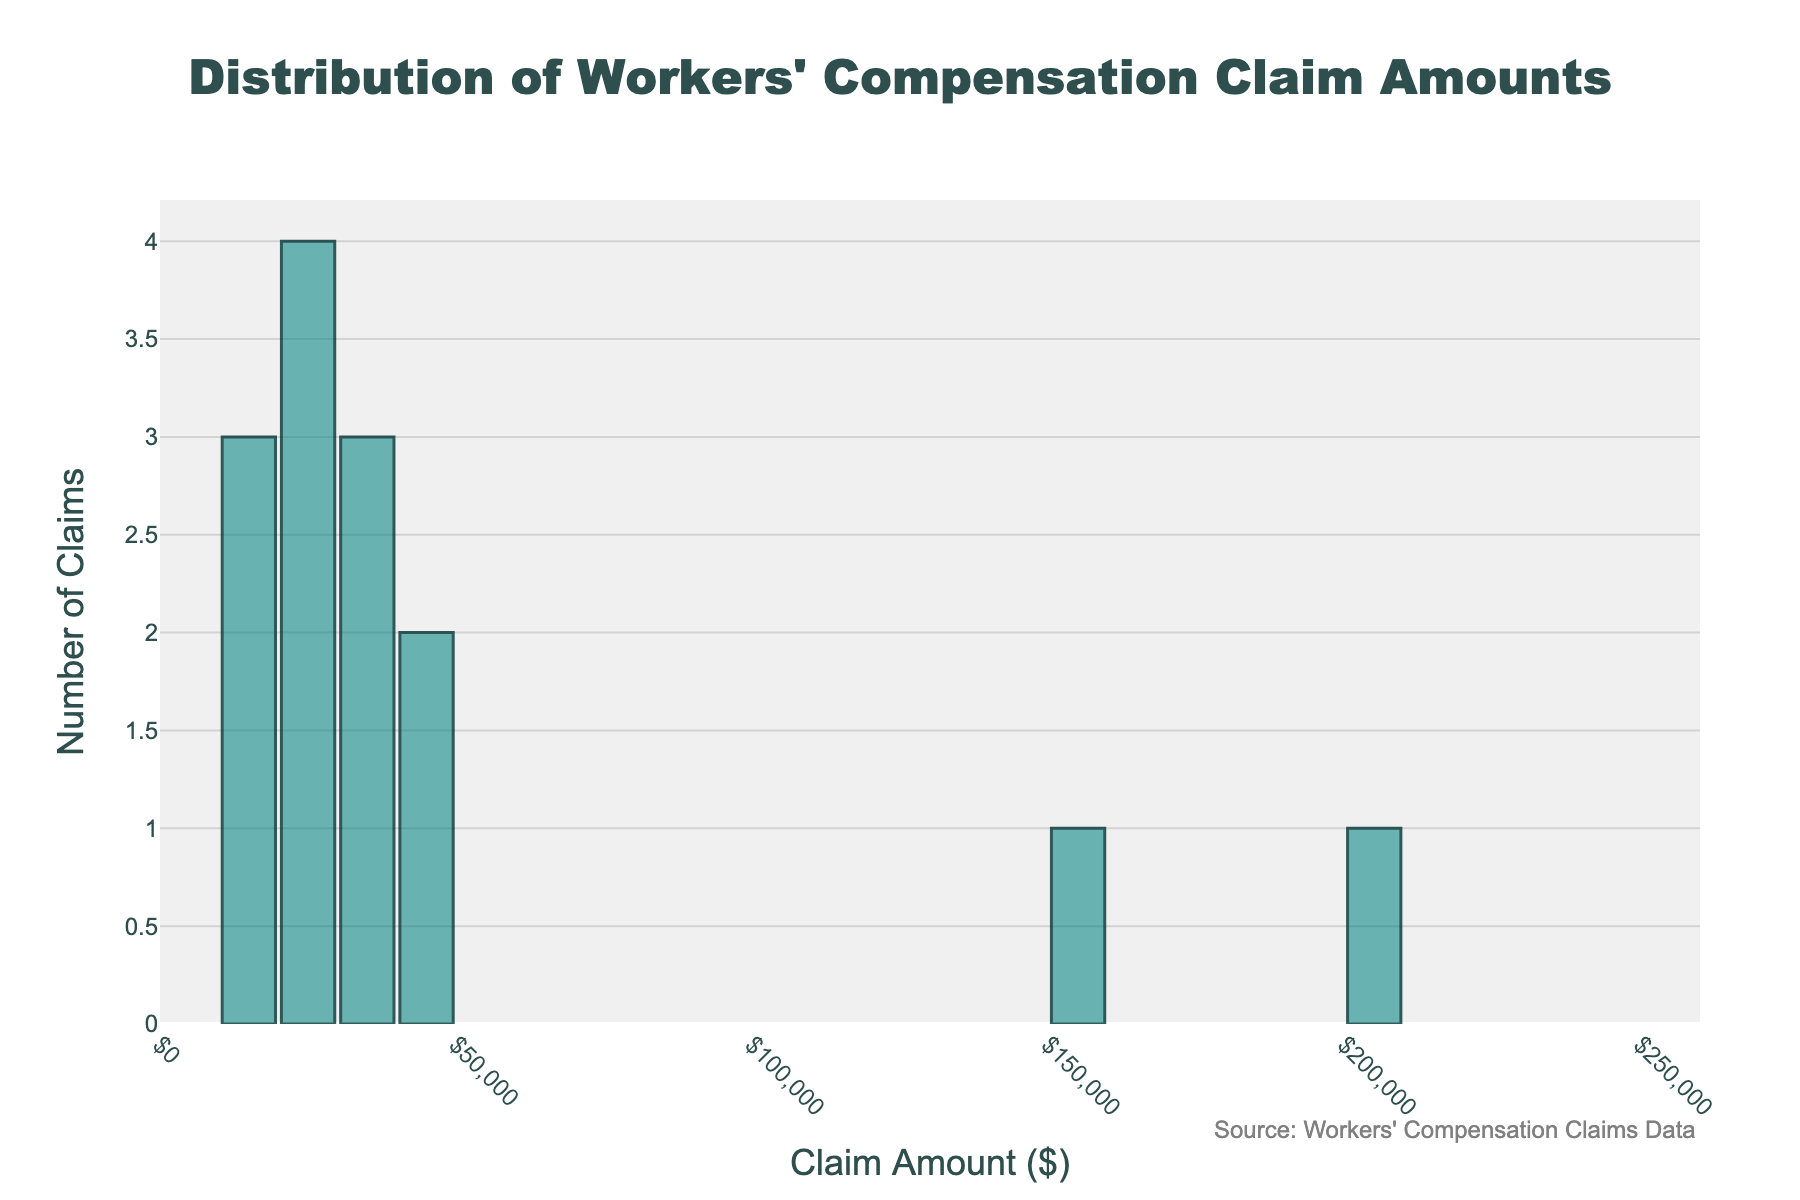What's the title of the histogram? The title is often displayed at the top of the histogram, it helps users identify what the plot represents. In this case, the title is clearly placed at the top center of the figure.
Answer: Distribution of Workers' Compensation Claim Amounts What does the x-axis represent? The x-axis is labeled with its representative variable, which in this histogram shows the range of claim amounts in dollars. This can be easily identified from the axis title.
Answer: Claim Amount ($) How many claims fall into the $20,000-$30,000 range? To find the number of claims in this range, observe the height of the bar spanning the $20,000-$30,000 interval on the x-axis. The y-axis will show the corresponding number of claims for that interval.
Answer: 3 claims How does the number of claims in the $0-$10,000 range compare to those in the $240,000-$250,000 range? Looking at the histogram, identify and compare the height of the bars in the $0-$10,000 range and the $240,000-$250,000 range. The y-axis will help in comparing the number of claims directly.
Answer: 0 claims vs 1 claim What is the typical bin size used in the histogram? The histogram uses evenly spaced bins to group the data. The distance between tick marks on the x-axis can reveal the bin size being used.
Answer: $10,000 Which injury type would likely fall into the highest claim amount bin? By looking at the x-axis and identifying the highest bin, observe which injury type aligns with this range based on the provided data.
Answer: Spinal Cord Injury Identify any gaps in the claim amounts presented in the histogram. A gap can be observed when there are no bars for certain ranges on the x-axis, indicating no claims fall within those amounts. Check for such empty intervals.
Answer: $0-$10,000 How many injury types have claim amounts exceeding $100,000? Based on the x-axis, count the number of bars starting from $100,000 upwards to find how many injury types have such high claim amounts.
Answer: 3 injury types Calculate the average claim amount for all the injury types. Sum up all the claim amounts provided, then divide by the number of injury types to get the average. (15000 + 25000 + 30000 + ... + 32000)/15 = (735000/15).
Answer: $49,000 Which injury type has the highest frequency in the histogram, considering its claim amount? Identify the tallest bar on the histogram and reference the corresponding claim amount to find out which injury type it represents. Match this with the data provided.
Answer: Back Strain 